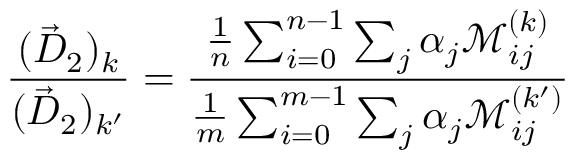<formula> <loc_0><loc_0><loc_500><loc_500>\frac { ( \vec { D } _ { 2 } ) _ { k } } { ( \vec { D } _ { 2 } ) _ { k ^ { \prime } } } = \frac { \frac { 1 } { n } \sum _ { i = 0 } ^ { n - 1 } \sum _ { j } \alpha _ { j } \mathcal { M } _ { i j } ^ { ( k ) } } { \frac { 1 } { m } \sum _ { i = 0 } ^ { m - 1 } \sum _ { j } \alpha _ { j } \mathcal { M } _ { i j } ^ { ( k ^ { \prime } ) } }</formula> 